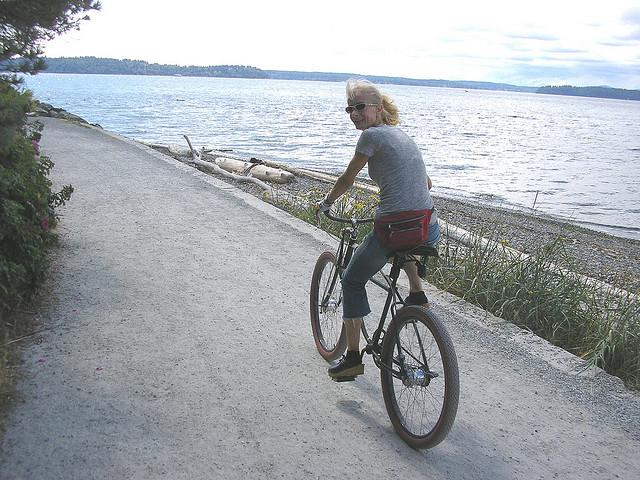Which wrong furnishing has the woman put on?

Choices:
A) pants
B) shoes
C) shirt
D) purse shoes 